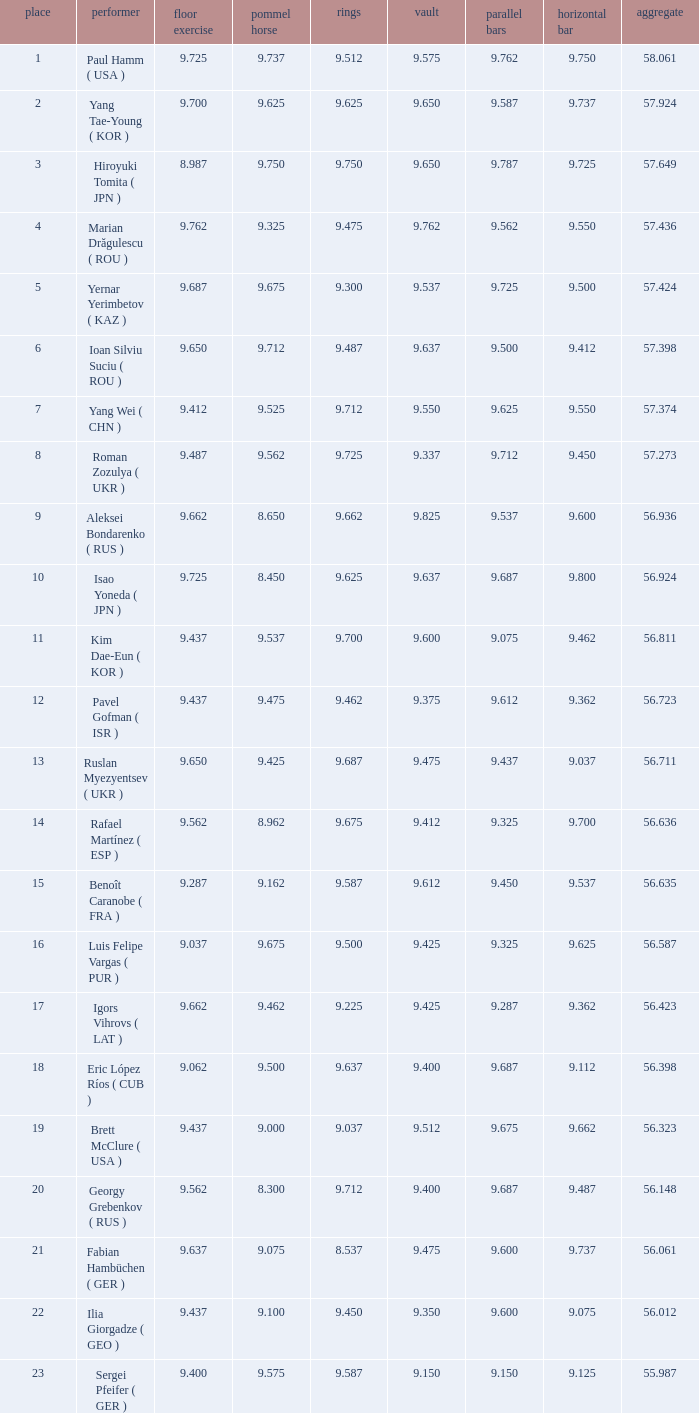What is the vault score for the total of 56.635? 9.612. Give me the full table as a dictionary. {'header': ['place', 'performer', 'floor exercise', 'pommel horse', 'rings', 'vault', 'parallel bars', 'horizontal bar', 'aggregate'], 'rows': [['1', 'Paul Hamm ( USA )', '9.725', '9.737', '9.512', '9.575', '9.762', '9.750', '58.061'], ['2', 'Yang Tae-Young ( KOR )', '9.700', '9.625', '9.625', '9.650', '9.587', '9.737', '57.924'], ['3', 'Hiroyuki Tomita ( JPN )', '8.987', '9.750', '9.750', '9.650', '9.787', '9.725', '57.649'], ['4', 'Marian Drăgulescu ( ROU )', '9.762', '9.325', '9.475', '9.762', '9.562', '9.550', '57.436'], ['5', 'Yernar Yerimbetov ( KAZ )', '9.687', '9.675', '9.300', '9.537', '9.725', '9.500', '57.424'], ['6', 'Ioan Silviu Suciu ( ROU )', '9.650', '9.712', '9.487', '9.637', '9.500', '9.412', '57.398'], ['7', 'Yang Wei ( CHN )', '9.412', '9.525', '9.712', '9.550', '9.625', '9.550', '57.374'], ['8', 'Roman Zozulya ( UKR )', '9.487', '9.562', '9.725', '9.337', '9.712', '9.450', '57.273'], ['9', 'Aleksei Bondarenko ( RUS )', '9.662', '8.650', '9.662', '9.825', '9.537', '9.600', '56.936'], ['10', 'Isao Yoneda ( JPN )', '9.725', '8.450', '9.625', '9.637', '9.687', '9.800', '56.924'], ['11', 'Kim Dae-Eun ( KOR )', '9.437', '9.537', '9.700', '9.600', '9.075', '9.462', '56.811'], ['12', 'Pavel Gofman ( ISR )', '9.437', '9.475', '9.462', '9.375', '9.612', '9.362', '56.723'], ['13', 'Ruslan Myezyentsev ( UKR )', '9.650', '9.425', '9.687', '9.475', '9.437', '9.037', '56.711'], ['14', 'Rafael Martínez ( ESP )', '9.562', '8.962', '9.675', '9.412', '9.325', '9.700', '56.636'], ['15', 'Benoît Caranobe ( FRA )', '9.287', '9.162', '9.587', '9.612', '9.450', '9.537', '56.635'], ['16', 'Luis Felipe Vargas ( PUR )', '9.037', '9.675', '9.500', '9.425', '9.325', '9.625', '56.587'], ['17', 'Igors Vihrovs ( LAT )', '9.662', '9.462', '9.225', '9.425', '9.287', '9.362', '56.423'], ['18', 'Eric López Ríos ( CUB )', '9.062', '9.500', '9.637', '9.400', '9.687', '9.112', '56.398'], ['19', 'Brett McClure ( USA )', '9.437', '9.000', '9.037', '9.512', '9.675', '9.662', '56.323'], ['20', 'Georgy Grebenkov ( RUS )', '9.562', '8.300', '9.712', '9.400', '9.687', '9.487', '56.148'], ['21', 'Fabian Hambüchen ( GER )', '9.637', '9.075', '8.537', '9.475', '9.600', '9.737', '56.061'], ['22', 'Ilia Giorgadze ( GEO )', '9.437', '9.100', '9.450', '9.350', '9.600', '9.075', '56.012'], ['23', 'Sergei Pfeifer ( GER )', '9.400', '9.575', '9.587', '9.150', '9.150', '9.125', '55.987']]} 